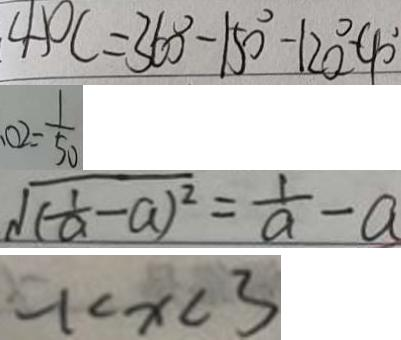Convert formula to latex. <formula><loc_0><loc_0><loc_500><loc_500>\angle A O C = 3 6 0 ^ { \circ } - 1 5 0 ^ { \circ } - 1 2 0 ^ { \circ } - 9 0 ^ { \circ } 
 . 0 2 = \frac { 1 } { 5 0 } 
 \sqrt { ( \frac { 1 } { a } - a ) ^ { 2 } } = \frac { 1 } { a } - a 
 - 1 < x < 3</formula> 